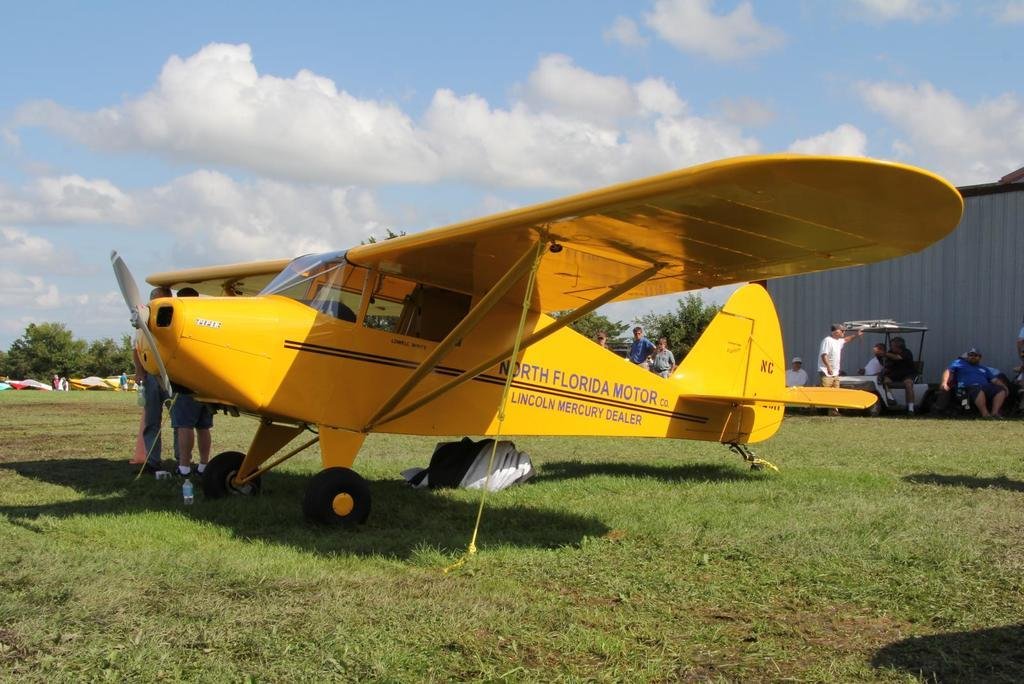<image>
Describe the image concisely. A yellow plane says North Florida Motor on it. 